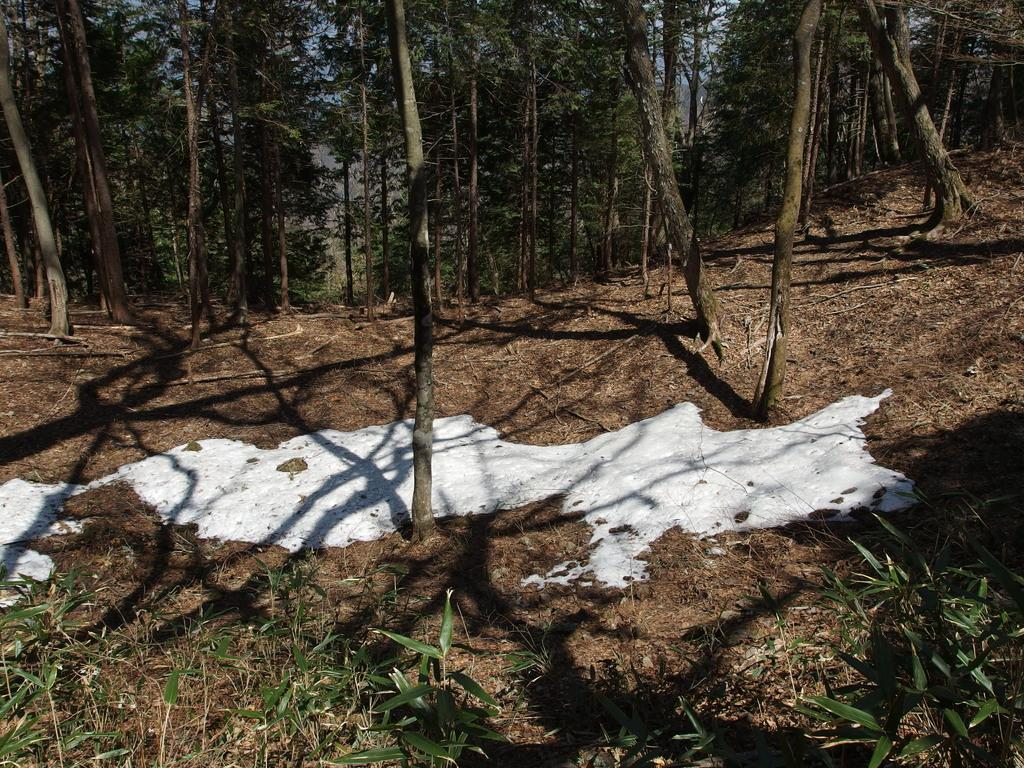What type of plants are on the ground in the image? There are plants on the ground in the image. What other type of vegetation is on the ground in the image? There are trees on the ground in the image. Can you see a hat on any of the plants in the image? There is no hat present on any of the plants in the image. Is there a horse grazing among the plants in the image? There is no horse present among the plants in the image. 